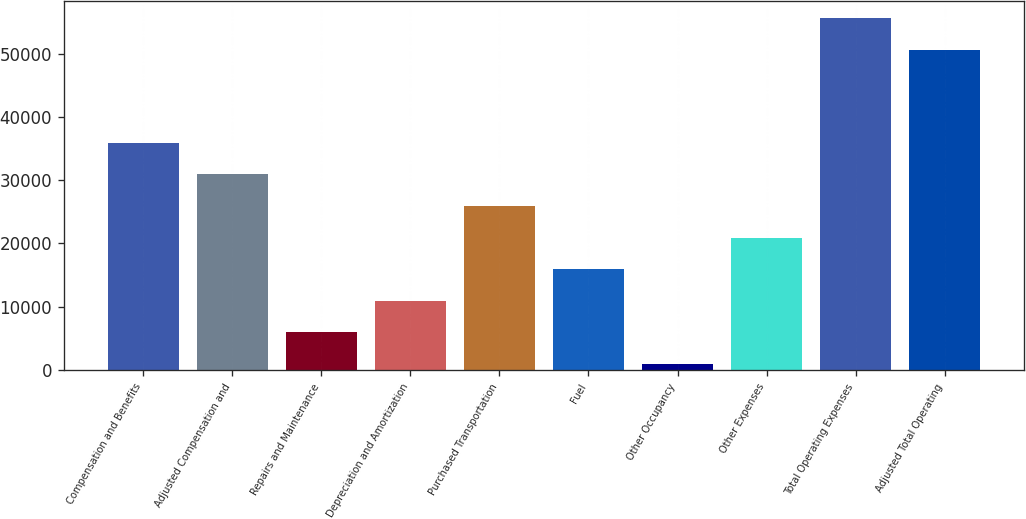Convert chart. <chart><loc_0><loc_0><loc_500><loc_500><bar_chart><fcel>Compensation and Benefits<fcel>Adjusted Compensation and<fcel>Repairs and Maintenance<fcel>Depreciation and Amortization<fcel>Purchased Transportation<fcel>Fuel<fcel>Other Occupancy<fcel>Other Expenses<fcel>Total Operating Expenses<fcel>Adjusted Total Operating<nl><fcel>35877.3<fcel>30910<fcel>5989.3<fcel>10956.6<fcel>25858.5<fcel>15923.9<fcel>1022<fcel>20891.2<fcel>55544.3<fcel>50577<nl></chart> 